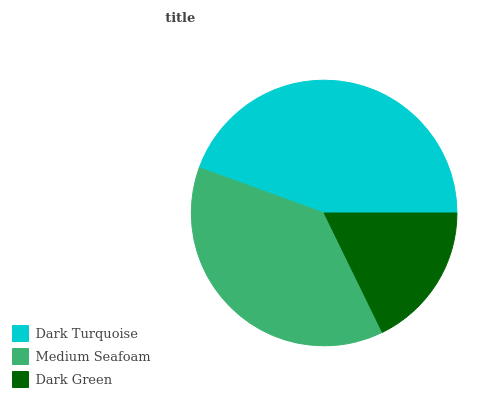Is Dark Green the minimum?
Answer yes or no. Yes. Is Dark Turquoise the maximum?
Answer yes or no. Yes. Is Medium Seafoam the minimum?
Answer yes or no. No. Is Medium Seafoam the maximum?
Answer yes or no. No. Is Dark Turquoise greater than Medium Seafoam?
Answer yes or no. Yes. Is Medium Seafoam less than Dark Turquoise?
Answer yes or no. Yes. Is Medium Seafoam greater than Dark Turquoise?
Answer yes or no. No. Is Dark Turquoise less than Medium Seafoam?
Answer yes or no. No. Is Medium Seafoam the high median?
Answer yes or no. Yes. Is Medium Seafoam the low median?
Answer yes or no. Yes. Is Dark Turquoise the high median?
Answer yes or no. No. Is Dark Green the low median?
Answer yes or no. No. 